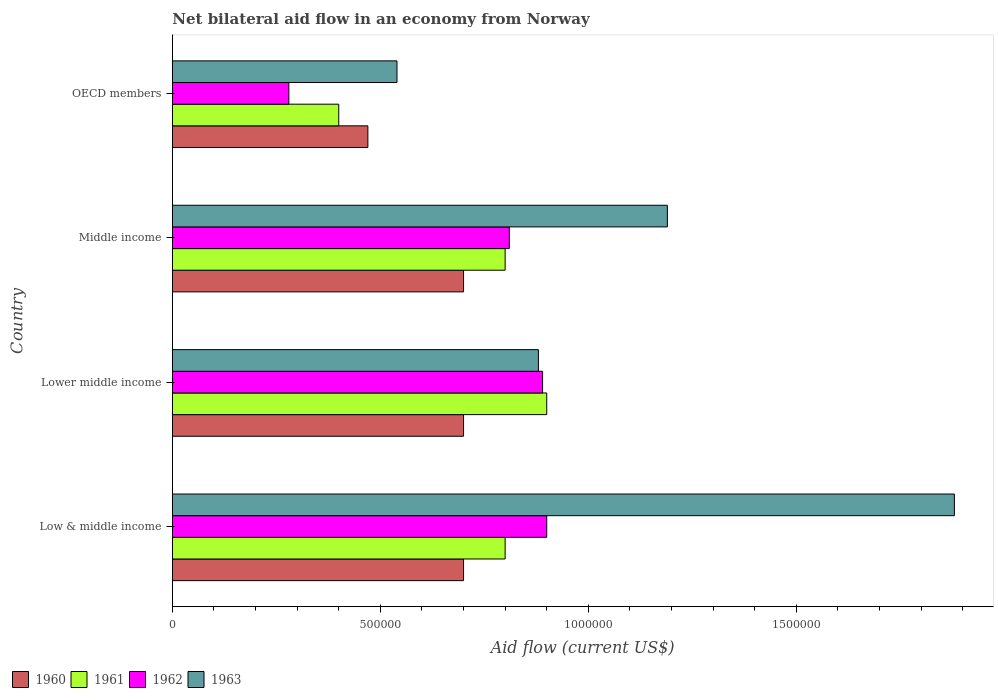How many bars are there on the 3rd tick from the top?
Offer a terse response. 4. How many bars are there on the 4th tick from the bottom?
Keep it short and to the point. 4. What is the label of the 4th group of bars from the top?
Provide a succinct answer. Low & middle income. In how many cases, is the number of bars for a given country not equal to the number of legend labels?
Make the answer very short. 0. What is the net bilateral aid flow in 1962 in Lower middle income?
Your answer should be very brief. 8.90e+05. Across all countries, what is the maximum net bilateral aid flow in 1962?
Your answer should be very brief. 9.00e+05. Across all countries, what is the minimum net bilateral aid flow in 1963?
Offer a terse response. 5.40e+05. In which country was the net bilateral aid flow in 1962 minimum?
Offer a terse response. OECD members. What is the total net bilateral aid flow in 1962 in the graph?
Offer a very short reply. 2.88e+06. What is the difference between the net bilateral aid flow in 1961 in OECD members and the net bilateral aid flow in 1962 in Low & middle income?
Give a very brief answer. -5.00e+05. What is the average net bilateral aid flow in 1961 per country?
Offer a terse response. 7.25e+05. What is the difference between the net bilateral aid flow in 1960 and net bilateral aid flow in 1962 in Low & middle income?
Make the answer very short. -2.00e+05. In how many countries, is the net bilateral aid flow in 1962 greater than 1200000 US$?
Your answer should be compact. 0. What is the ratio of the net bilateral aid flow in 1961 in Lower middle income to that in OECD members?
Give a very brief answer. 2.25. Is the net bilateral aid flow in 1962 in Low & middle income less than that in Middle income?
Your response must be concise. No. Is the difference between the net bilateral aid flow in 1960 in Low & middle income and Middle income greater than the difference between the net bilateral aid flow in 1962 in Low & middle income and Middle income?
Your answer should be very brief. No. What is the difference between the highest and the lowest net bilateral aid flow in 1962?
Ensure brevity in your answer.  6.20e+05. Is the sum of the net bilateral aid flow in 1963 in Low & middle income and OECD members greater than the maximum net bilateral aid flow in 1962 across all countries?
Make the answer very short. Yes. Is it the case that in every country, the sum of the net bilateral aid flow in 1961 and net bilateral aid flow in 1962 is greater than the sum of net bilateral aid flow in 1963 and net bilateral aid flow in 1960?
Keep it short and to the point. No. What does the 3rd bar from the bottom in OECD members represents?
Ensure brevity in your answer.  1962. Is it the case that in every country, the sum of the net bilateral aid flow in 1960 and net bilateral aid flow in 1963 is greater than the net bilateral aid flow in 1962?
Your answer should be very brief. Yes. How many bars are there?
Offer a very short reply. 16. Are all the bars in the graph horizontal?
Provide a short and direct response. Yes. What is the difference between two consecutive major ticks on the X-axis?
Your answer should be very brief. 5.00e+05. Are the values on the major ticks of X-axis written in scientific E-notation?
Give a very brief answer. No. How many legend labels are there?
Provide a succinct answer. 4. How are the legend labels stacked?
Your answer should be very brief. Horizontal. What is the title of the graph?
Offer a terse response. Net bilateral aid flow in an economy from Norway. Does "1982" appear as one of the legend labels in the graph?
Provide a short and direct response. No. What is the label or title of the Y-axis?
Your response must be concise. Country. What is the Aid flow (current US$) in 1960 in Low & middle income?
Your response must be concise. 7.00e+05. What is the Aid flow (current US$) of 1961 in Low & middle income?
Your answer should be compact. 8.00e+05. What is the Aid flow (current US$) of 1962 in Low & middle income?
Ensure brevity in your answer.  9.00e+05. What is the Aid flow (current US$) of 1963 in Low & middle income?
Provide a succinct answer. 1.88e+06. What is the Aid flow (current US$) in 1962 in Lower middle income?
Make the answer very short. 8.90e+05. What is the Aid flow (current US$) of 1963 in Lower middle income?
Provide a short and direct response. 8.80e+05. What is the Aid flow (current US$) of 1960 in Middle income?
Make the answer very short. 7.00e+05. What is the Aid flow (current US$) in 1961 in Middle income?
Provide a succinct answer. 8.00e+05. What is the Aid flow (current US$) in 1962 in Middle income?
Provide a short and direct response. 8.10e+05. What is the Aid flow (current US$) of 1963 in Middle income?
Make the answer very short. 1.19e+06. What is the Aid flow (current US$) in 1961 in OECD members?
Give a very brief answer. 4.00e+05. What is the Aid flow (current US$) in 1962 in OECD members?
Your answer should be compact. 2.80e+05. What is the Aid flow (current US$) of 1963 in OECD members?
Offer a very short reply. 5.40e+05. Across all countries, what is the maximum Aid flow (current US$) in 1960?
Your response must be concise. 7.00e+05. Across all countries, what is the maximum Aid flow (current US$) of 1962?
Your response must be concise. 9.00e+05. Across all countries, what is the maximum Aid flow (current US$) of 1963?
Keep it short and to the point. 1.88e+06. Across all countries, what is the minimum Aid flow (current US$) of 1961?
Offer a very short reply. 4.00e+05. Across all countries, what is the minimum Aid flow (current US$) in 1963?
Give a very brief answer. 5.40e+05. What is the total Aid flow (current US$) in 1960 in the graph?
Give a very brief answer. 2.57e+06. What is the total Aid flow (current US$) in 1961 in the graph?
Offer a very short reply. 2.90e+06. What is the total Aid flow (current US$) in 1962 in the graph?
Provide a succinct answer. 2.88e+06. What is the total Aid flow (current US$) in 1963 in the graph?
Your answer should be very brief. 4.49e+06. What is the difference between the Aid flow (current US$) in 1961 in Low & middle income and that in Lower middle income?
Provide a succinct answer. -1.00e+05. What is the difference between the Aid flow (current US$) in 1962 in Low & middle income and that in Lower middle income?
Keep it short and to the point. 10000. What is the difference between the Aid flow (current US$) in 1962 in Low & middle income and that in Middle income?
Give a very brief answer. 9.00e+04. What is the difference between the Aid flow (current US$) in 1963 in Low & middle income and that in Middle income?
Ensure brevity in your answer.  6.90e+05. What is the difference between the Aid flow (current US$) of 1961 in Low & middle income and that in OECD members?
Provide a succinct answer. 4.00e+05. What is the difference between the Aid flow (current US$) in 1962 in Low & middle income and that in OECD members?
Your answer should be very brief. 6.20e+05. What is the difference between the Aid flow (current US$) of 1963 in Low & middle income and that in OECD members?
Make the answer very short. 1.34e+06. What is the difference between the Aid flow (current US$) of 1962 in Lower middle income and that in Middle income?
Provide a short and direct response. 8.00e+04. What is the difference between the Aid flow (current US$) in 1963 in Lower middle income and that in Middle income?
Give a very brief answer. -3.10e+05. What is the difference between the Aid flow (current US$) of 1960 in Lower middle income and that in OECD members?
Ensure brevity in your answer.  2.30e+05. What is the difference between the Aid flow (current US$) in 1962 in Lower middle income and that in OECD members?
Offer a very short reply. 6.10e+05. What is the difference between the Aid flow (current US$) of 1961 in Middle income and that in OECD members?
Your response must be concise. 4.00e+05. What is the difference between the Aid flow (current US$) of 1962 in Middle income and that in OECD members?
Provide a short and direct response. 5.30e+05. What is the difference between the Aid flow (current US$) of 1963 in Middle income and that in OECD members?
Give a very brief answer. 6.50e+05. What is the difference between the Aid flow (current US$) of 1960 in Low & middle income and the Aid flow (current US$) of 1961 in Lower middle income?
Provide a succinct answer. -2.00e+05. What is the difference between the Aid flow (current US$) in 1960 in Low & middle income and the Aid flow (current US$) in 1963 in Lower middle income?
Provide a succinct answer. -1.80e+05. What is the difference between the Aid flow (current US$) in 1961 in Low & middle income and the Aid flow (current US$) in 1963 in Lower middle income?
Provide a succinct answer. -8.00e+04. What is the difference between the Aid flow (current US$) of 1962 in Low & middle income and the Aid flow (current US$) of 1963 in Lower middle income?
Keep it short and to the point. 2.00e+04. What is the difference between the Aid flow (current US$) of 1960 in Low & middle income and the Aid flow (current US$) of 1961 in Middle income?
Your answer should be compact. -1.00e+05. What is the difference between the Aid flow (current US$) of 1960 in Low & middle income and the Aid flow (current US$) of 1962 in Middle income?
Your answer should be compact. -1.10e+05. What is the difference between the Aid flow (current US$) of 1960 in Low & middle income and the Aid flow (current US$) of 1963 in Middle income?
Make the answer very short. -4.90e+05. What is the difference between the Aid flow (current US$) of 1961 in Low & middle income and the Aid flow (current US$) of 1962 in Middle income?
Make the answer very short. -10000. What is the difference between the Aid flow (current US$) in 1961 in Low & middle income and the Aid flow (current US$) in 1963 in Middle income?
Make the answer very short. -3.90e+05. What is the difference between the Aid flow (current US$) of 1960 in Low & middle income and the Aid flow (current US$) of 1961 in OECD members?
Your answer should be compact. 3.00e+05. What is the difference between the Aid flow (current US$) of 1960 in Low & middle income and the Aid flow (current US$) of 1962 in OECD members?
Provide a short and direct response. 4.20e+05. What is the difference between the Aid flow (current US$) of 1960 in Low & middle income and the Aid flow (current US$) of 1963 in OECD members?
Make the answer very short. 1.60e+05. What is the difference between the Aid flow (current US$) of 1961 in Low & middle income and the Aid flow (current US$) of 1962 in OECD members?
Offer a very short reply. 5.20e+05. What is the difference between the Aid flow (current US$) of 1962 in Low & middle income and the Aid flow (current US$) of 1963 in OECD members?
Ensure brevity in your answer.  3.60e+05. What is the difference between the Aid flow (current US$) of 1960 in Lower middle income and the Aid flow (current US$) of 1962 in Middle income?
Provide a succinct answer. -1.10e+05. What is the difference between the Aid flow (current US$) in 1960 in Lower middle income and the Aid flow (current US$) in 1963 in Middle income?
Ensure brevity in your answer.  -4.90e+05. What is the difference between the Aid flow (current US$) of 1962 in Lower middle income and the Aid flow (current US$) of 1963 in Middle income?
Provide a succinct answer. -3.00e+05. What is the difference between the Aid flow (current US$) in 1960 in Lower middle income and the Aid flow (current US$) in 1962 in OECD members?
Make the answer very short. 4.20e+05. What is the difference between the Aid flow (current US$) in 1961 in Lower middle income and the Aid flow (current US$) in 1962 in OECD members?
Your answer should be compact. 6.20e+05. What is the difference between the Aid flow (current US$) in 1961 in Lower middle income and the Aid flow (current US$) in 1963 in OECD members?
Provide a succinct answer. 3.60e+05. What is the difference between the Aid flow (current US$) in 1960 in Middle income and the Aid flow (current US$) in 1962 in OECD members?
Provide a succinct answer. 4.20e+05. What is the difference between the Aid flow (current US$) in 1961 in Middle income and the Aid flow (current US$) in 1962 in OECD members?
Make the answer very short. 5.20e+05. What is the difference between the Aid flow (current US$) of 1961 in Middle income and the Aid flow (current US$) of 1963 in OECD members?
Offer a very short reply. 2.60e+05. What is the difference between the Aid flow (current US$) in 1962 in Middle income and the Aid flow (current US$) in 1963 in OECD members?
Offer a very short reply. 2.70e+05. What is the average Aid flow (current US$) of 1960 per country?
Provide a succinct answer. 6.42e+05. What is the average Aid flow (current US$) in 1961 per country?
Ensure brevity in your answer.  7.25e+05. What is the average Aid flow (current US$) of 1962 per country?
Give a very brief answer. 7.20e+05. What is the average Aid flow (current US$) in 1963 per country?
Keep it short and to the point. 1.12e+06. What is the difference between the Aid flow (current US$) in 1960 and Aid flow (current US$) in 1962 in Low & middle income?
Offer a terse response. -2.00e+05. What is the difference between the Aid flow (current US$) of 1960 and Aid flow (current US$) of 1963 in Low & middle income?
Offer a very short reply. -1.18e+06. What is the difference between the Aid flow (current US$) of 1961 and Aid flow (current US$) of 1963 in Low & middle income?
Make the answer very short. -1.08e+06. What is the difference between the Aid flow (current US$) in 1962 and Aid flow (current US$) in 1963 in Low & middle income?
Provide a short and direct response. -9.80e+05. What is the difference between the Aid flow (current US$) of 1960 and Aid flow (current US$) of 1962 in Lower middle income?
Give a very brief answer. -1.90e+05. What is the difference between the Aid flow (current US$) in 1960 and Aid flow (current US$) in 1963 in Lower middle income?
Provide a succinct answer. -1.80e+05. What is the difference between the Aid flow (current US$) in 1960 and Aid flow (current US$) in 1961 in Middle income?
Provide a short and direct response. -1.00e+05. What is the difference between the Aid flow (current US$) of 1960 and Aid flow (current US$) of 1962 in Middle income?
Your answer should be compact. -1.10e+05. What is the difference between the Aid flow (current US$) of 1960 and Aid flow (current US$) of 1963 in Middle income?
Your response must be concise. -4.90e+05. What is the difference between the Aid flow (current US$) in 1961 and Aid flow (current US$) in 1962 in Middle income?
Your answer should be compact. -10000. What is the difference between the Aid flow (current US$) of 1961 and Aid flow (current US$) of 1963 in Middle income?
Give a very brief answer. -3.90e+05. What is the difference between the Aid flow (current US$) in 1962 and Aid flow (current US$) in 1963 in Middle income?
Offer a very short reply. -3.80e+05. What is the difference between the Aid flow (current US$) of 1960 and Aid flow (current US$) of 1963 in OECD members?
Keep it short and to the point. -7.00e+04. What is the difference between the Aid flow (current US$) in 1961 and Aid flow (current US$) in 1963 in OECD members?
Provide a short and direct response. -1.40e+05. What is the ratio of the Aid flow (current US$) in 1962 in Low & middle income to that in Lower middle income?
Your answer should be compact. 1.01. What is the ratio of the Aid flow (current US$) in 1963 in Low & middle income to that in Lower middle income?
Make the answer very short. 2.14. What is the ratio of the Aid flow (current US$) in 1960 in Low & middle income to that in Middle income?
Your response must be concise. 1. What is the ratio of the Aid flow (current US$) in 1962 in Low & middle income to that in Middle income?
Ensure brevity in your answer.  1.11. What is the ratio of the Aid flow (current US$) of 1963 in Low & middle income to that in Middle income?
Offer a terse response. 1.58. What is the ratio of the Aid flow (current US$) of 1960 in Low & middle income to that in OECD members?
Keep it short and to the point. 1.49. What is the ratio of the Aid flow (current US$) in 1961 in Low & middle income to that in OECD members?
Make the answer very short. 2. What is the ratio of the Aid flow (current US$) in 1962 in Low & middle income to that in OECD members?
Make the answer very short. 3.21. What is the ratio of the Aid flow (current US$) in 1963 in Low & middle income to that in OECD members?
Provide a short and direct response. 3.48. What is the ratio of the Aid flow (current US$) of 1962 in Lower middle income to that in Middle income?
Provide a succinct answer. 1.1. What is the ratio of the Aid flow (current US$) in 1963 in Lower middle income to that in Middle income?
Keep it short and to the point. 0.74. What is the ratio of the Aid flow (current US$) of 1960 in Lower middle income to that in OECD members?
Keep it short and to the point. 1.49. What is the ratio of the Aid flow (current US$) in 1961 in Lower middle income to that in OECD members?
Offer a very short reply. 2.25. What is the ratio of the Aid flow (current US$) in 1962 in Lower middle income to that in OECD members?
Make the answer very short. 3.18. What is the ratio of the Aid flow (current US$) of 1963 in Lower middle income to that in OECD members?
Provide a short and direct response. 1.63. What is the ratio of the Aid flow (current US$) of 1960 in Middle income to that in OECD members?
Offer a very short reply. 1.49. What is the ratio of the Aid flow (current US$) of 1961 in Middle income to that in OECD members?
Provide a short and direct response. 2. What is the ratio of the Aid flow (current US$) in 1962 in Middle income to that in OECD members?
Your answer should be compact. 2.89. What is the ratio of the Aid flow (current US$) in 1963 in Middle income to that in OECD members?
Provide a short and direct response. 2.2. What is the difference between the highest and the second highest Aid flow (current US$) of 1963?
Your answer should be compact. 6.90e+05. What is the difference between the highest and the lowest Aid flow (current US$) in 1962?
Your answer should be compact. 6.20e+05. What is the difference between the highest and the lowest Aid flow (current US$) of 1963?
Provide a short and direct response. 1.34e+06. 